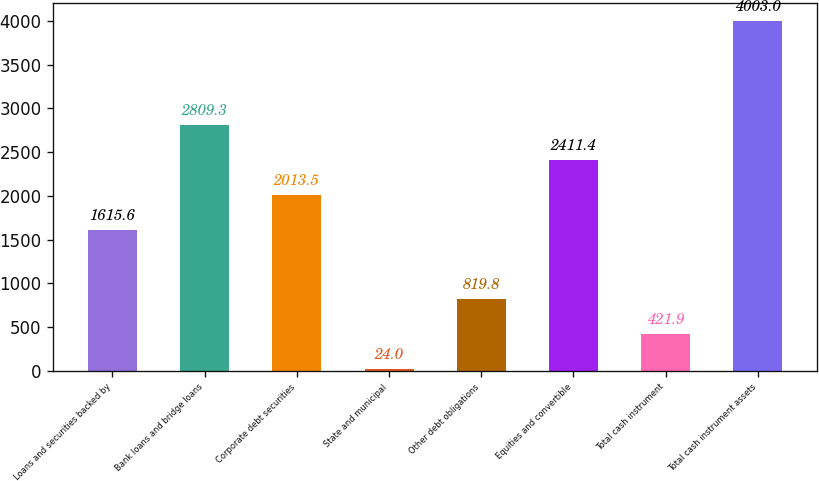Convert chart to OTSL. <chart><loc_0><loc_0><loc_500><loc_500><bar_chart><fcel>Loans and securities backed by<fcel>Bank loans and bridge loans<fcel>Corporate debt securities<fcel>State and municipal<fcel>Other debt obligations<fcel>Equities and convertible<fcel>Total cash instrument<fcel>Total cash instrument assets<nl><fcel>1615.6<fcel>2809.3<fcel>2013.5<fcel>24<fcel>819.8<fcel>2411.4<fcel>421.9<fcel>4003<nl></chart> 